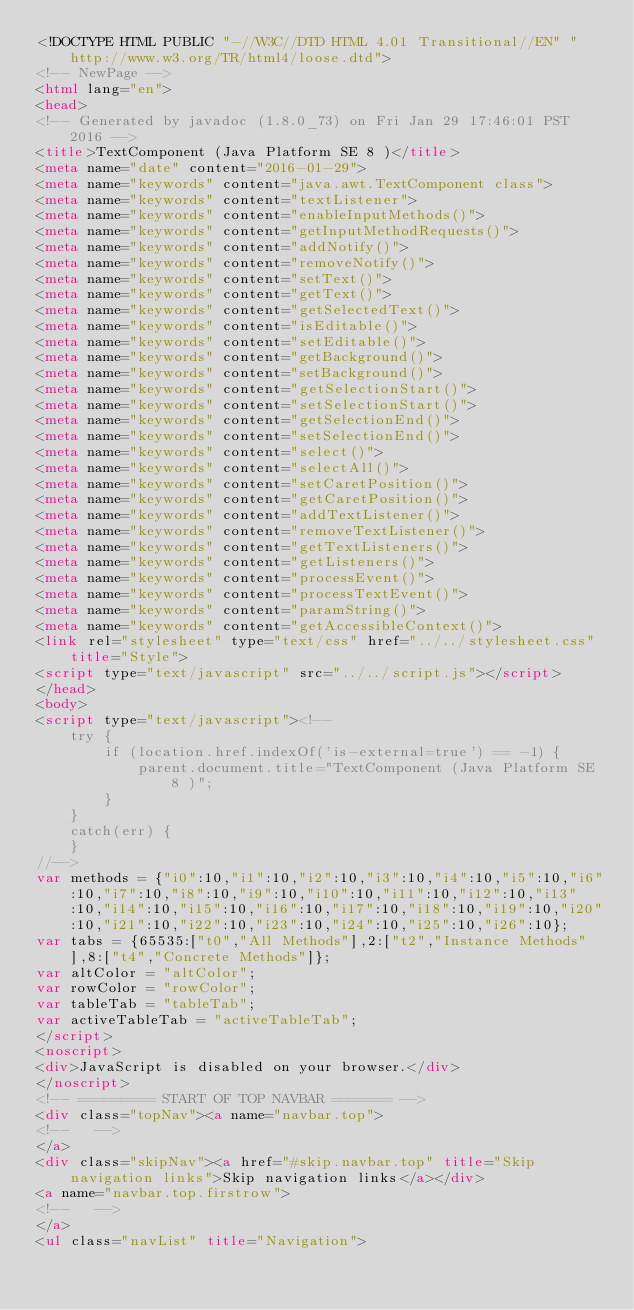Convert code to text. <code><loc_0><loc_0><loc_500><loc_500><_HTML_><!DOCTYPE HTML PUBLIC "-//W3C//DTD HTML 4.01 Transitional//EN" "http://www.w3.org/TR/html4/loose.dtd">
<!-- NewPage -->
<html lang="en">
<head>
<!-- Generated by javadoc (1.8.0_73) on Fri Jan 29 17:46:01 PST 2016 -->
<title>TextComponent (Java Platform SE 8 )</title>
<meta name="date" content="2016-01-29">
<meta name="keywords" content="java.awt.TextComponent class">
<meta name="keywords" content="textListener">
<meta name="keywords" content="enableInputMethods()">
<meta name="keywords" content="getInputMethodRequests()">
<meta name="keywords" content="addNotify()">
<meta name="keywords" content="removeNotify()">
<meta name="keywords" content="setText()">
<meta name="keywords" content="getText()">
<meta name="keywords" content="getSelectedText()">
<meta name="keywords" content="isEditable()">
<meta name="keywords" content="setEditable()">
<meta name="keywords" content="getBackground()">
<meta name="keywords" content="setBackground()">
<meta name="keywords" content="getSelectionStart()">
<meta name="keywords" content="setSelectionStart()">
<meta name="keywords" content="getSelectionEnd()">
<meta name="keywords" content="setSelectionEnd()">
<meta name="keywords" content="select()">
<meta name="keywords" content="selectAll()">
<meta name="keywords" content="setCaretPosition()">
<meta name="keywords" content="getCaretPosition()">
<meta name="keywords" content="addTextListener()">
<meta name="keywords" content="removeTextListener()">
<meta name="keywords" content="getTextListeners()">
<meta name="keywords" content="getListeners()">
<meta name="keywords" content="processEvent()">
<meta name="keywords" content="processTextEvent()">
<meta name="keywords" content="paramString()">
<meta name="keywords" content="getAccessibleContext()">
<link rel="stylesheet" type="text/css" href="../../stylesheet.css" title="Style">
<script type="text/javascript" src="../../script.js"></script>
</head>
<body>
<script type="text/javascript"><!--
    try {
        if (location.href.indexOf('is-external=true') == -1) {
            parent.document.title="TextComponent (Java Platform SE 8 )";
        }
    }
    catch(err) {
    }
//-->
var methods = {"i0":10,"i1":10,"i2":10,"i3":10,"i4":10,"i5":10,"i6":10,"i7":10,"i8":10,"i9":10,"i10":10,"i11":10,"i12":10,"i13":10,"i14":10,"i15":10,"i16":10,"i17":10,"i18":10,"i19":10,"i20":10,"i21":10,"i22":10,"i23":10,"i24":10,"i25":10,"i26":10};
var tabs = {65535:["t0","All Methods"],2:["t2","Instance Methods"],8:["t4","Concrete Methods"]};
var altColor = "altColor";
var rowColor = "rowColor";
var tableTab = "tableTab";
var activeTableTab = "activeTableTab";
</script>
<noscript>
<div>JavaScript is disabled on your browser.</div>
</noscript>
<!-- ========= START OF TOP NAVBAR ======= -->
<div class="topNav"><a name="navbar.top">
<!--   -->
</a>
<div class="skipNav"><a href="#skip.navbar.top" title="Skip navigation links">Skip navigation links</a></div>
<a name="navbar.top.firstrow">
<!--   -->
</a>
<ul class="navList" title="Navigation"></code> 